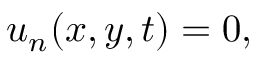Convert formula to latex. <formula><loc_0><loc_0><loc_500><loc_500>u _ { n } ( x , y , t ) = 0 ,</formula> 